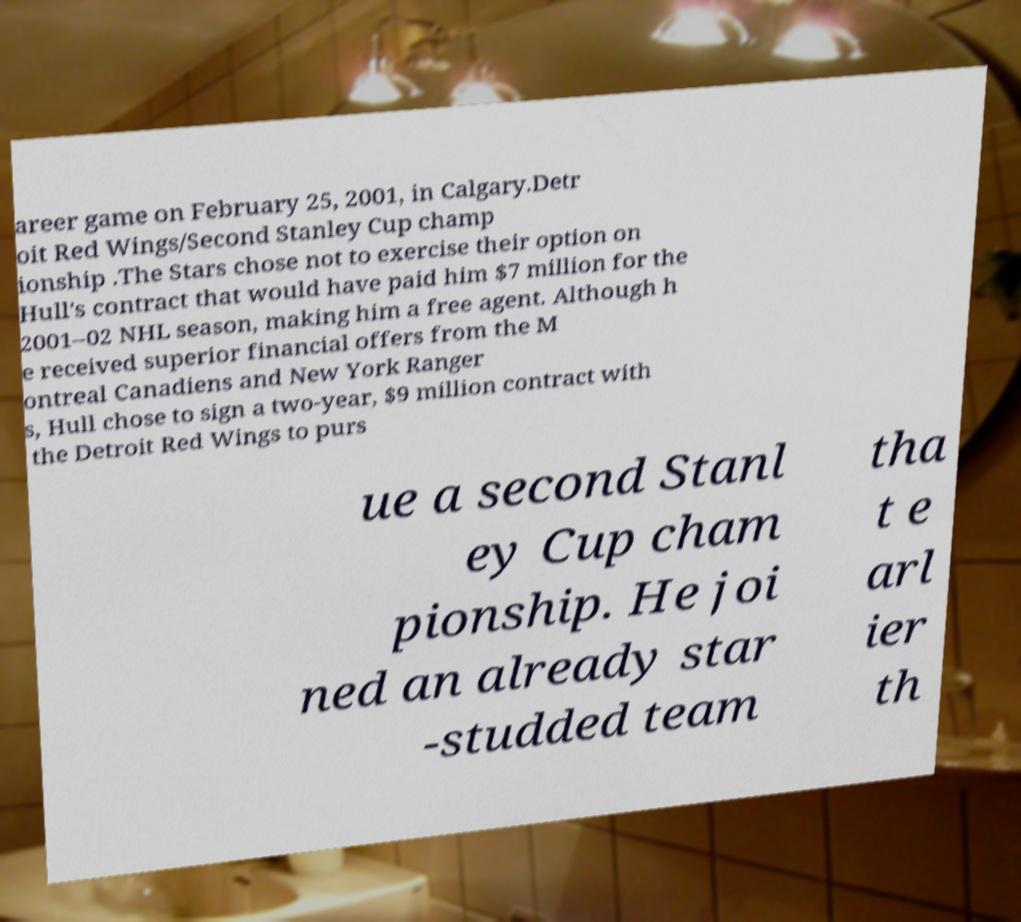Please identify and transcribe the text found in this image. areer game on February 25, 2001, in Calgary.Detr oit Red Wings/Second Stanley Cup champ ionship .The Stars chose not to exercise their option on Hull's contract that would have paid him $7 million for the 2001–02 NHL season, making him a free agent. Although h e received superior financial offers from the M ontreal Canadiens and New York Ranger s, Hull chose to sign a two-year, $9 million contract with the Detroit Red Wings to purs ue a second Stanl ey Cup cham pionship. He joi ned an already star -studded team tha t e arl ier th 